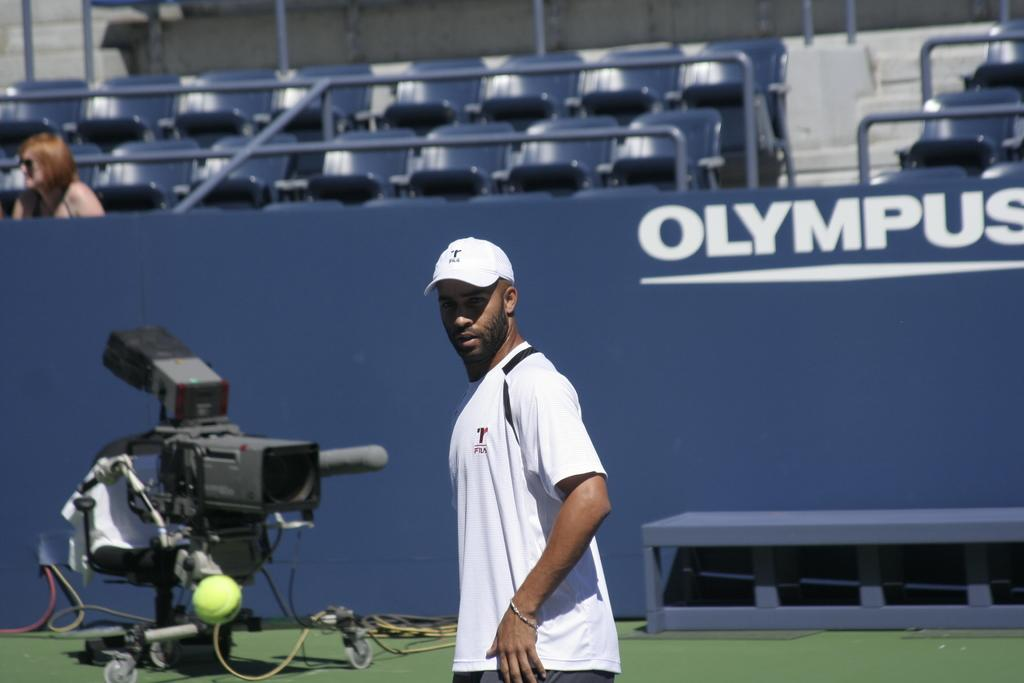<image>
Offer a succinct explanation of the picture presented. a man walking to a tv camera in front of a sign for Olympus 